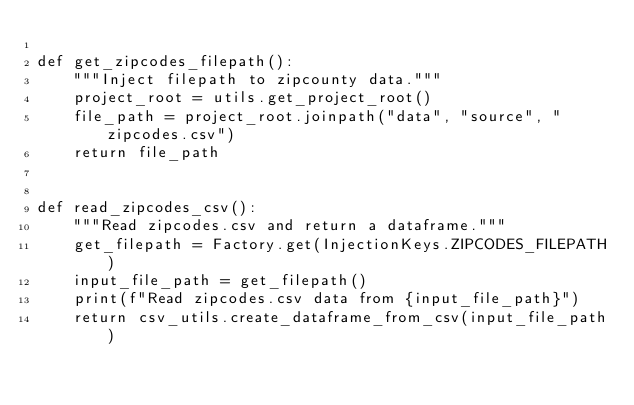Convert code to text. <code><loc_0><loc_0><loc_500><loc_500><_Python_>
def get_zipcodes_filepath():
    """Inject filepath to zipcounty data."""
    project_root = utils.get_project_root()
    file_path = project_root.joinpath("data", "source", "zipcodes.csv")
    return file_path


def read_zipcodes_csv():
    """Read zipcodes.csv and return a dataframe."""
    get_filepath = Factory.get(InjectionKeys.ZIPCODES_FILEPATH)
    input_file_path = get_filepath()
    print(f"Read zipcodes.csv data from {input_file_path}")
    return csv_utils.create_dataframe_from_csv(input_file_path)
</code> 